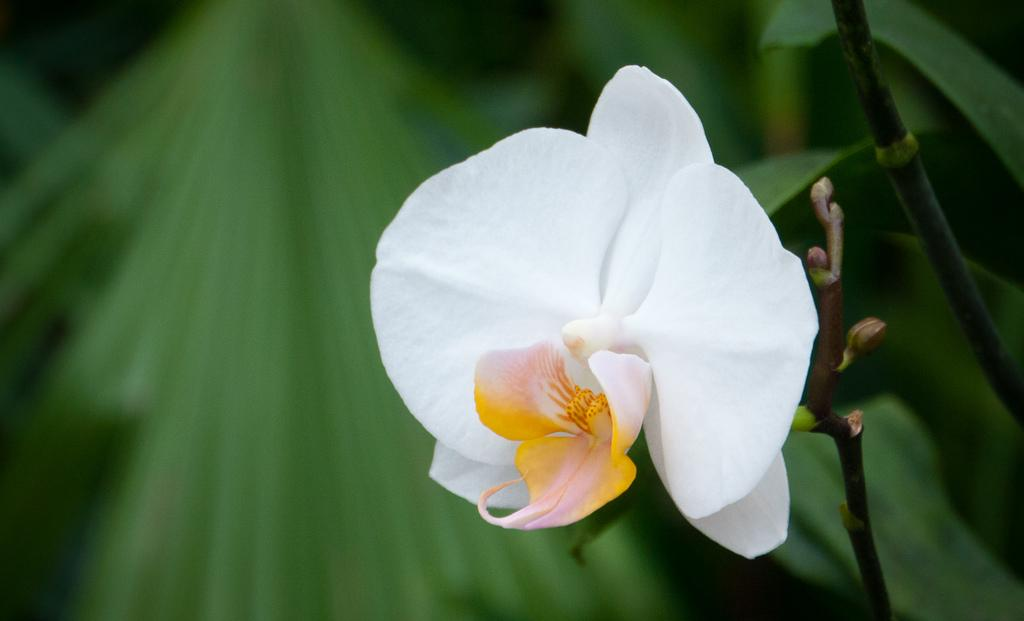What is the main subject of the image? There is a flower in the image. Can you describe the colors of the flower? The flower has white, yellow, and light pink colors. What else can be seen in the image besides the flower? There are green leaves in the image. What type of dock can be seen near the flower in the image? There is no dock present in the image; it only features a flower and green leaves. What emotion does the flower appear to be expressing in the image? The flower is an inanimate object and does not express emotions like fear. 